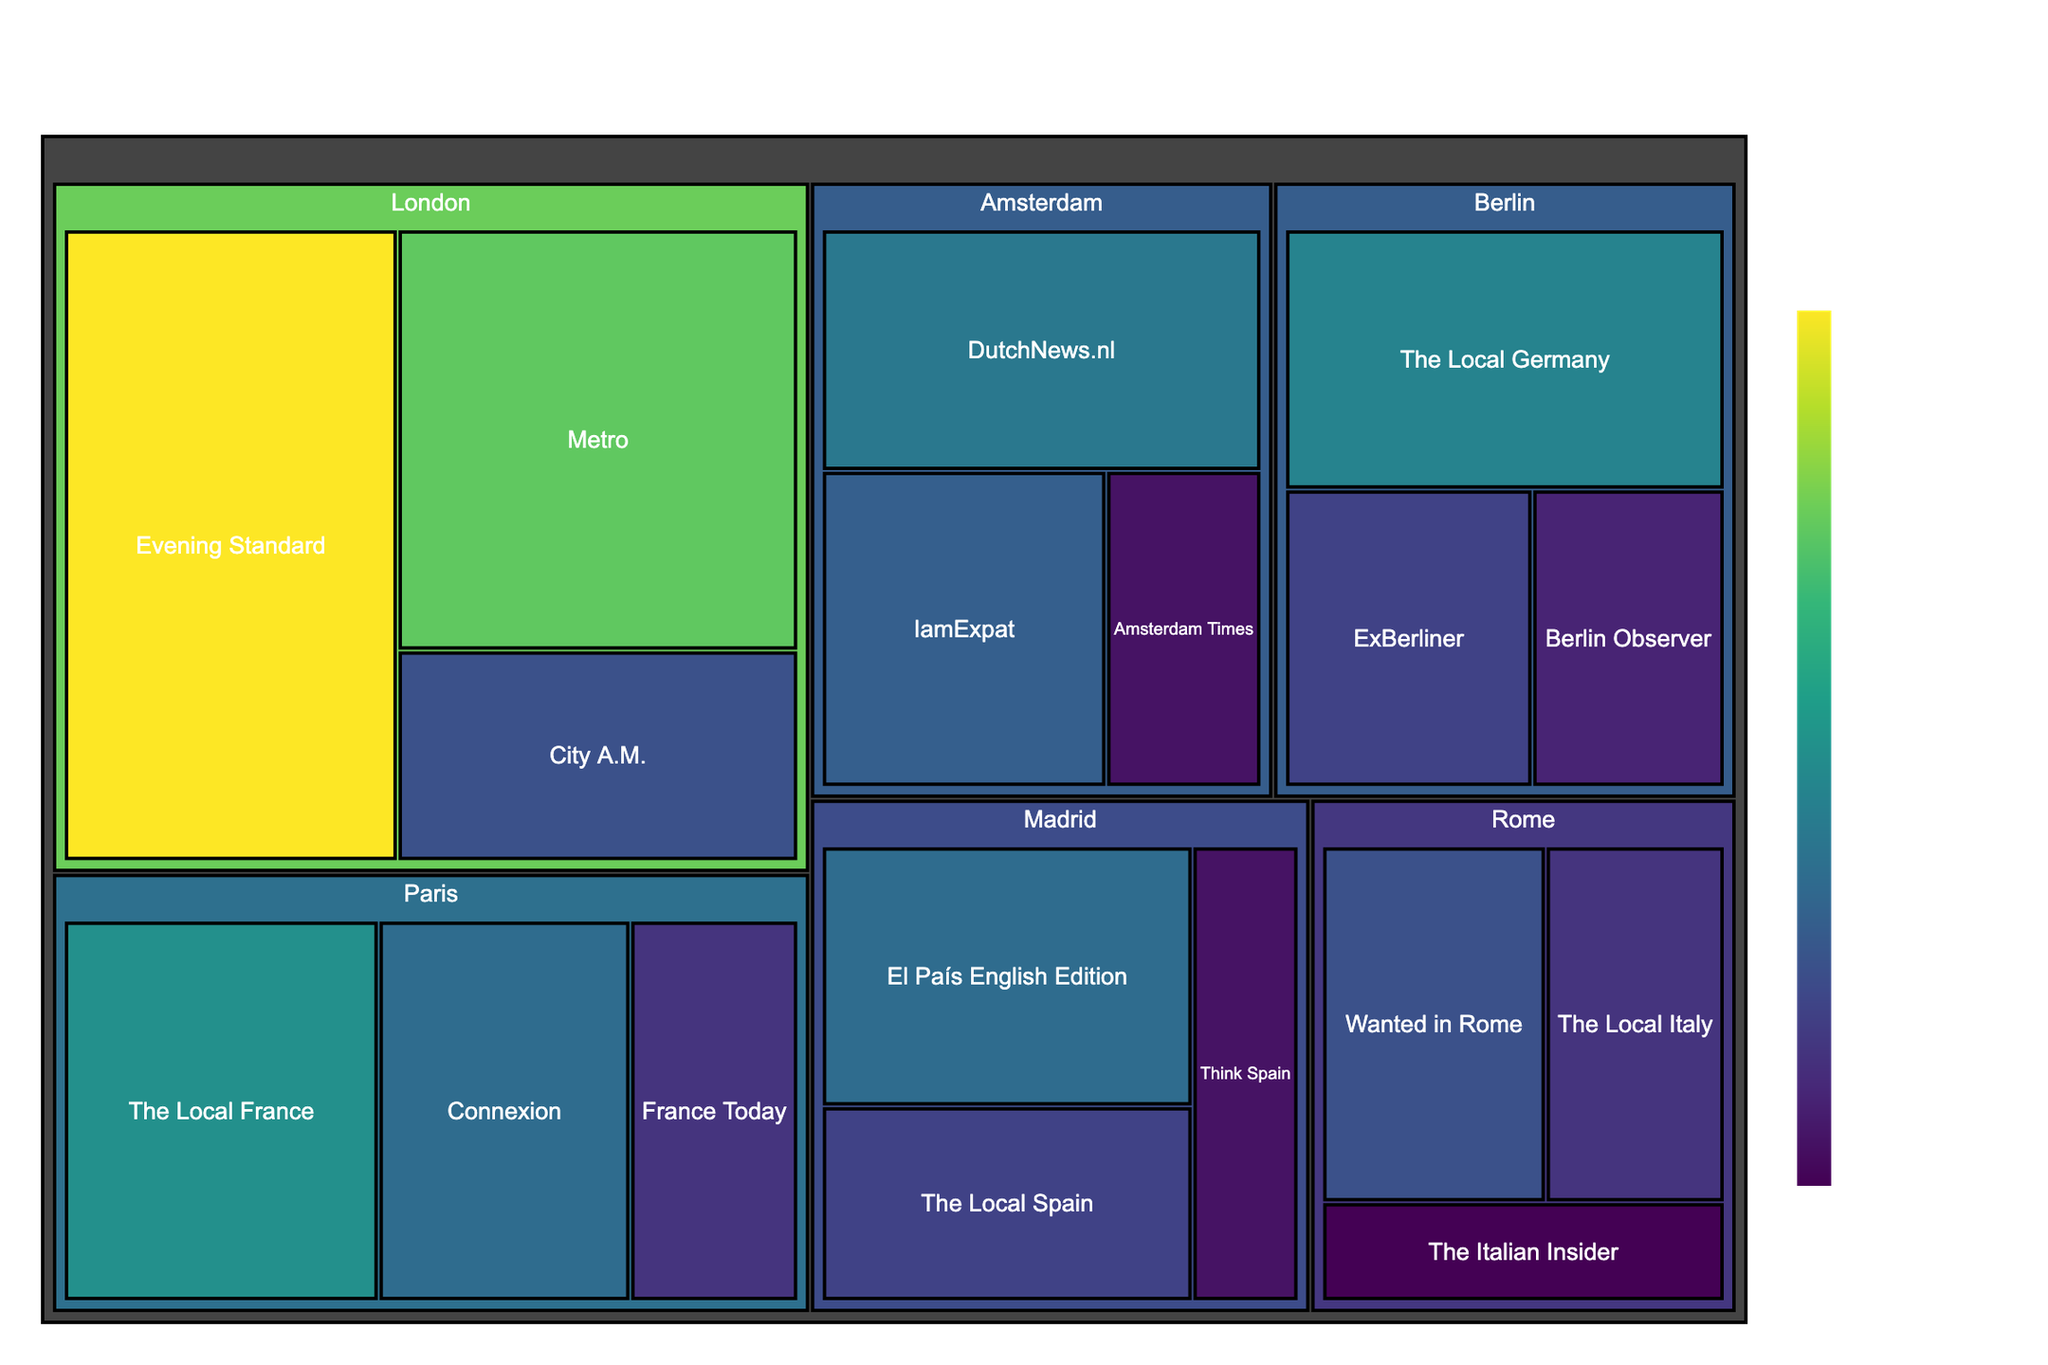What's the city with the highest total market share for English-language newspapers? To determine which city has the highest total market share, sum the market share percentages of all the newspapers in each city. Paris: 15+12+8=35; London: 25+20+10=55; Berlin: 14+9+7=30; Amsterdam: 13+11+6=30; Rome: 10+8+5=23; Madrid: 12+9+6=27. London has the highest total market share.
Answer: London Which newspaper in Paris has the lowest market share? In Paris, the market shares of the newspapers are: The Local France (15), Connexion (12), and France Today (8). France Today has the lowest market share.
Answer: France Today What's the combined market share of The Local newspapers across all cities? The Local newspapers and their market shares are The Local France (15), The Local Germany (14), The Local Italy (8), and The Local Spain (9). The combined market share is 15+14+8+9=46.
Answer: 46 Which city has the smallest market share for its leading newspaper? Identify the leading newspaper in each city and compare their market shares: Paris (The Local France: 15), London (Evening Standard: 25), Berlin (The Local Germany: 14), Amsterdam (DutchNews.nl: 13), Rome (Wanted in Rome: 10), Madrid (El País English Edition: 12). Rome, with Wanted in Rome having a 10% share, has the smallest leading newspaper market share.
Answer: Rome What is the total market share of all newspapers in cities starting with the letter "M"? Cities starting with the letter "M" include Madrid. Summing their market shares: El País English Edition (12), The Local Spain (9), and Think Spain (6), we get 12+9+6=27.
Answer: 27 Which newspaper has the largest market share in Berlin? In Berlin, the market shares of the newspapers are: The Local Germany (14), ExBerliner (9), and Berlin Observer (7). The Local Germany has the largest market share.
Answer: The Local Germany Compare the market shares of Metro in London with the combined market share of all newspapers in Rome. Metro in London has a market share of 20%. Newspapers in Rome have the following shares: Wanted in Rome (10), The Local Italy (8), The Italian Insider (5). The combined market share in Rome is 10+8+5=23%. Therefore, 20% < 23%.
Answer: The combined market share of newspapers in Rome is larger than Metro in London by 3% What is the difference in market share between the largest and smallest newspapers in Amsterdam? In Amsterdam, the market shares are DutchNews.nl (13), IamExpat (11), and Amsterdam Times (6). The difference between the largest (DutchNews.nl) and smallest (Amsterdam Times) market shares is 13-6=7.
Answer: 7 Which city has the highest number of newspapers listed? Count the number of newspapers for each city: Paris (3), London (3), Berlin (3), Amsterdam (3), Rome (3), Madrid (3). All cities have the same number of newspapers listed.
Answer: All cities have the same number 